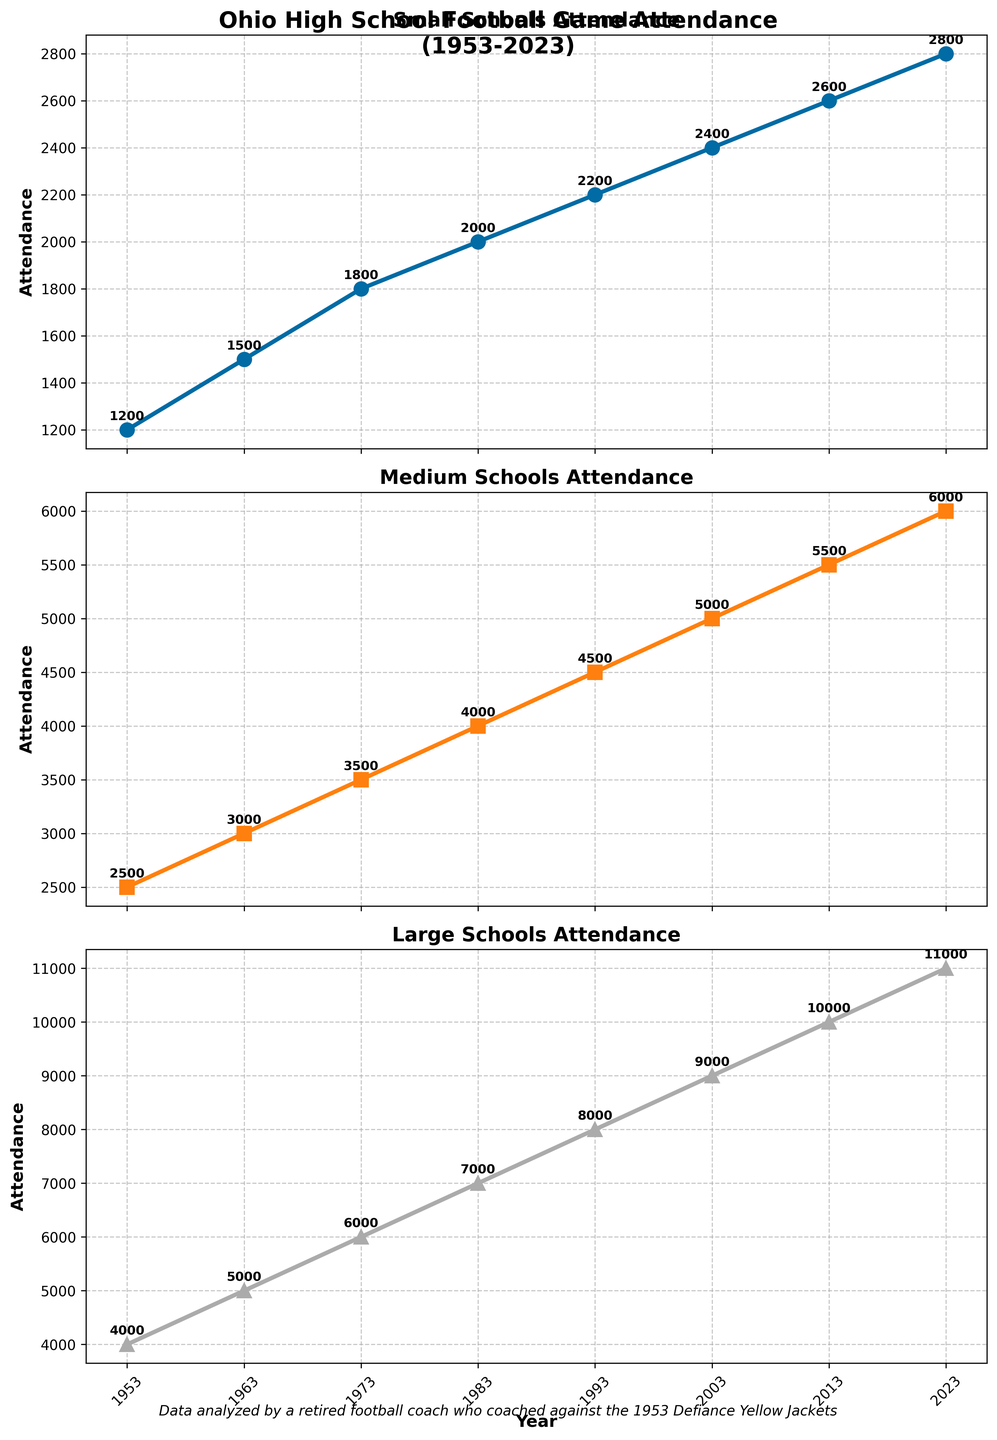What is the overall title of the figure? The overall title is shown at the top of the figure in large, bold font, indicating it summarizes the entire visual content.
Answer: Ohio High School Football Game Attendance (1953-2023) What is the attendance figure for Small Schools in 1973? Look at the subplot titled "Small Schools Attendance" and locate the data point corresponding to the year 1973. The attendance value is annotated next to the data point.
Answer: 1800 How does the attendance in 1993 for Large Schools compare to that in 2013? Identify the attendance figures for Large Schools in both 1993 and 2013 from the subplot titled "Large Schools Attendance." Compare the two numbers.
Answer: 1993 had 8000, while 2013 had 10000, so 2013 had higher attendance What is the overall trend in attendance for Medium Schools from 1953 to 2023? Observe the data points in the subplot titled "Medium Schools Attendance." The attendance figures increase over time, indicating an upward trend.
Answer: Increasing Which school size had the highest attendance in 1963? Compare the attendance figures for all three school sizes in the year 1963. The subplot annotations provide these values.
Answer: Large Schools What's the difference in attendance between Small Schools and Large Schools in 1983? Find the attendance for both Small Schools and Large Schools in 1983 from their respective subplots. Subtract the attendance of Small Schools from that of Large Schools.
Answer: 7000 - 2000 = 5000 Which school size shows the most significant increase in attendance from 1953 to 2023? Calculate the increase in attendance for each school size by subtracting the 1953 value from the 2023 value for each subplot and compare these differences.
Answer: Large Schools; increase of 11000 - 4000 = 7000 What's the average attendance for Medium Schools over the entire period? Sum the attendance values for Medium Schools across all years and divide by the number of years (8).
Answer: (2500+3000+3500+4000+4500+5000+5500+6000)/8 = 4250 In which year did Small Schools see the highest attendance figure, and what was it? Check the "Small Schools Attendance" subplot to find the highest annotated value and its corresponding year.
Answer: 2023; 2800 